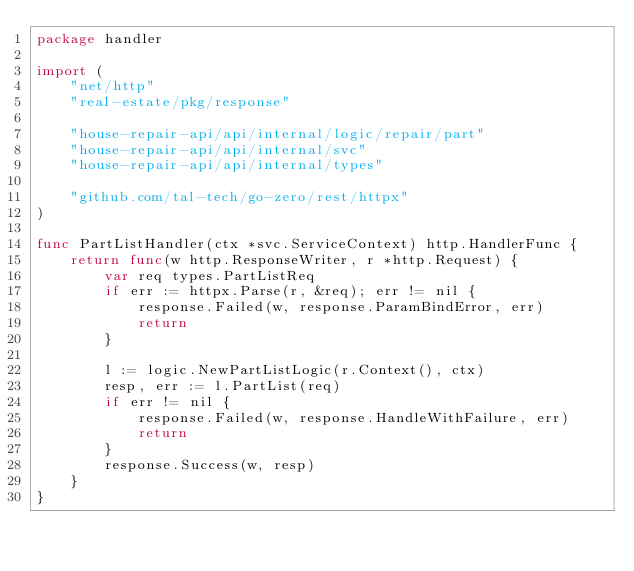<code> <loc_0><loc_0><loc_500><loc_500><_Go_>package handler

import (
	"net/http"
	"real-estate/pkg/response"

	"house-repair-api/api/internal/logic/repair/part"
	"house-repair-api/api/internal/svc"
	"house-repair-api/api/internal/types"

	"github.com/tal-tech/go-zero/rest/httpx"
)

func PartListHandler(ctx *svc.ServiceContext) http.HandlerFunc {
	return func(w http.ResponseWriter, r *http.Request) {
		var req types.PartListReq
		if err := httpx.Parse(r, &req); err != nil {
			response.Failed(w, response.ParamBindError, err)
			return
		}

		l := logic.NewPartListLogic(r.Context(), ctx)
		resp, err := l.PartList(req)
		if err != nil {
			response.Failed(w, response.HandleWithFailure, err)
			return
		}
		response.Success(w, resp)
	}
}
</code> 